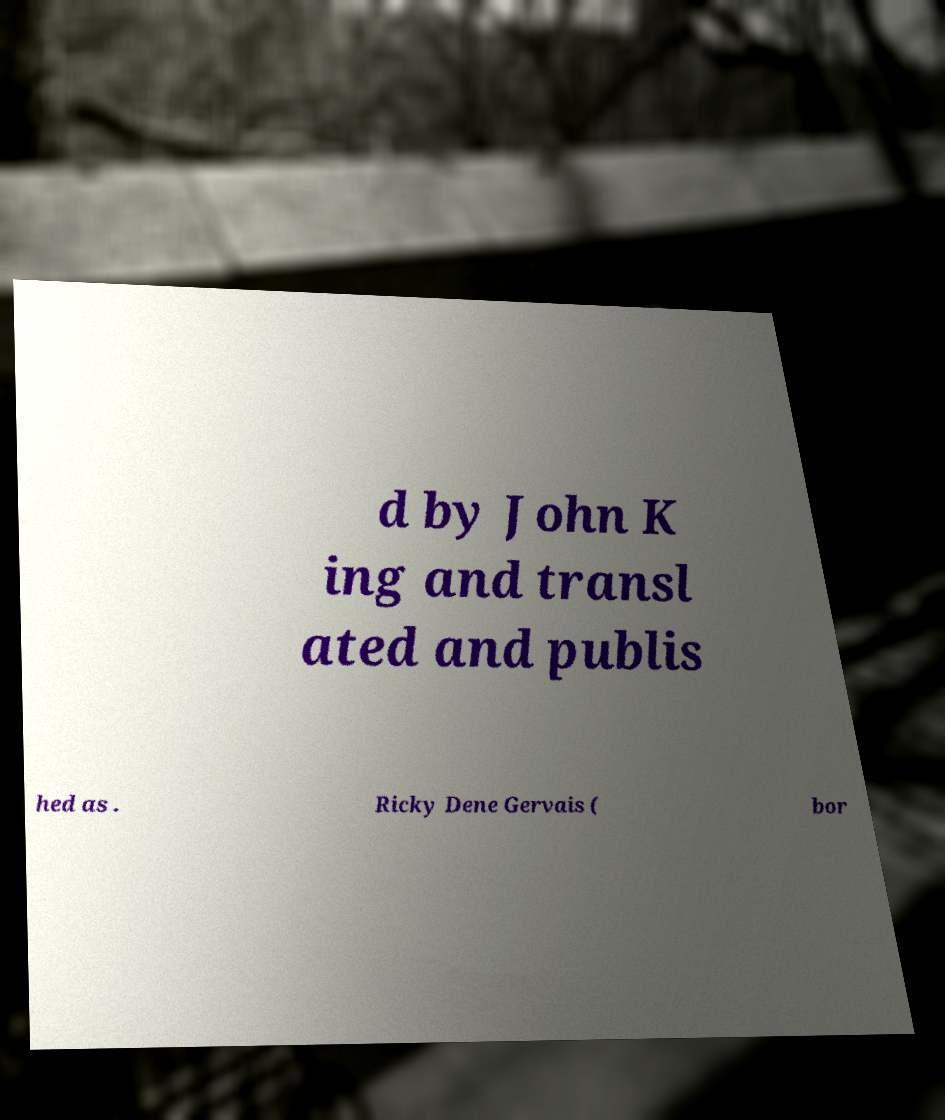Can you read and provide the text displayed in the image?This photo seems to have some interesting text. Can you extract and type it out for me? d by John K ing and transl ated and publis hed as . Ricky Dene Gervais ( bor 